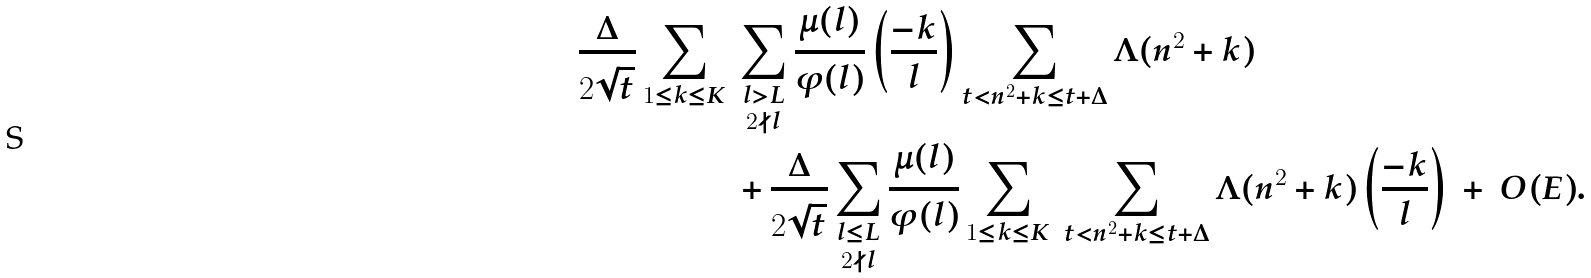Convert formula to latex. <formula><loc_0><loc_0><loc_500><loc_500>\frac { \Delta } { 2 \sqrt { t } } \sum _ { 1 \leq k \leq K } \ & \sum _ { \substack { l > L \\ 2 \nmid l } } \frac { \mu ( l ) } { \varphi ( l ) } \left ( \frac { - k } { l } \right ) \sum _ { t < n ^ { 2 } + k \leq t + \Delta } \Lambda ( n ^ { 2 } + k ) \\ & + \frac { \Delta } { 2 \sqrt { t } } \sum _ { \substack { l \leq L \\ 2 \nmid l } } \frac { \mu ( l ) } { \varphi ( l ) } \sum _ { 1 \leq k \leq K } \ \sum _ { t < n ^ { 2 } + k \leq t + \Delta } \Lambda ( n ^ { 2 } + k ) \left ( \frac { - k } { l } \right ) \ + \ O ( E ) .</formula> 